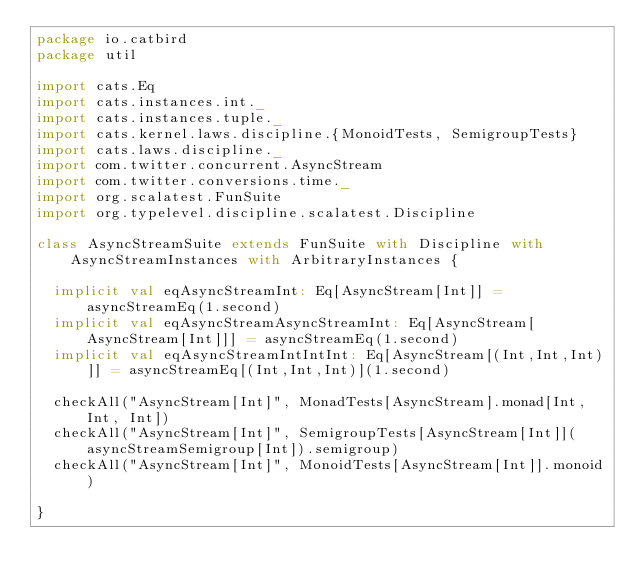<code> <loc_0><loc_0><loc_500><loc_500><_Scala_>package io.catbird
package util

import cats.Eq
import cats.instances.int._
import cats.instances.tuple._
import cats.kernel.laws.discipline.{MonoidTests, SemigroupTests}
import cats.laws.discipline._
import com.twitter.concurrent.AsyncStream
import com.twitter.conversions.time._
import org.scalatest.FunSuite
import org.typelevel.discipline.scalatest.Discipline

class AsyncStreamSuite extends FunSuite with Discipline with AsyncStreamInstances with ArbitraryInstances {

  implicit val eqAsyncStreamInt: Eq[AsyncStream[Int]] = asyncStreamEq(1.second)
  implicit val eqAsyncStreamAsyncStreamInt: Eq[AsyncStream[AsyncStream[Int]]] = asyncStreamEq(1.second)
  implicit val eqAsyncStreamIntIntInt: Eq[AsyncStream[(Int,Int,Int)]] = asyncStreamEq[(Int,Int,Int)](1.second)

  checkAll("AsyncStream[Int]", MonadTests[AsyncStream].monad[Int, Int, Int])
  checkAll("AsyncStream[Int]", SemigroupTests[AsyncStream[Int]](asyncStreamSemigroup[Int]).semigroup)
  checkAll("AsyncStream[Int]", MonoidTests[AsyncStream[Int]].monoid)
  
}
</code> 